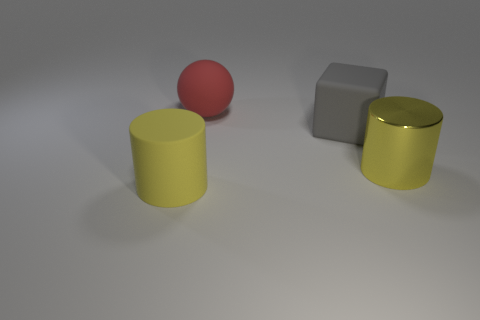Add 1 tiny gray rubber things. How many objects exist? 5 Subtract all spheres. How many objects are left? 3 Add 1 gray rubber cylinders. How many gray rubber cylinders exist? 1 Subtract 0 brown balls. How many objects are left? 4 Subtract all large yellow cylinders. Subtract all gray metal cylinders. How many objects are left? 2 Add 2 large red objects. How many large red objects are left? 3 